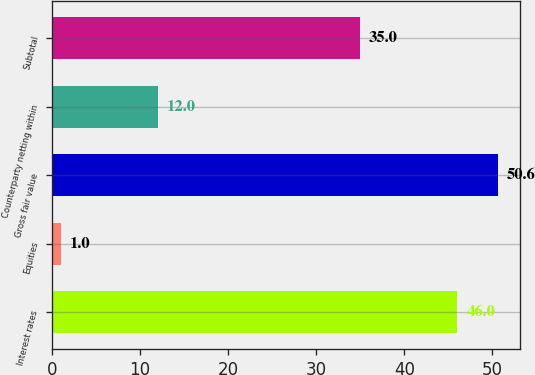<chart> <loc_0><loc_0><loc_500><loc_500><bar_chart><fcel>Interest rates<fcel>Equities<fcel>Gross fair value<fcel>Counterparty netting within<fcel>Subtotal<nl><fcel>46<fcel>1<fcel>50.6<fcel>12<fcel>35<nl></chart> 